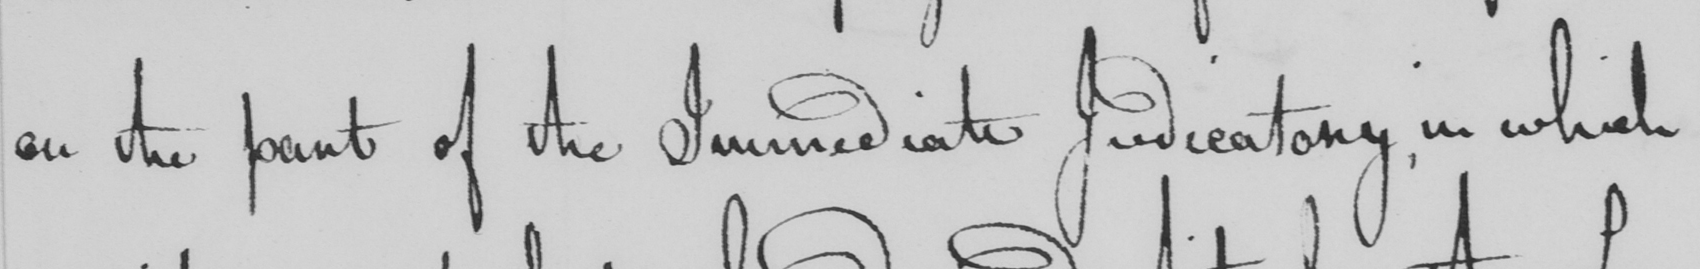Can you tell me what this handwritten text says? on the part of the Immediate Judicatory, in which 